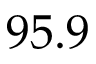Convert formula to latex. <formula><loc_0><loc_0><loc_500><loc_500>9 5 . 9</formula> 